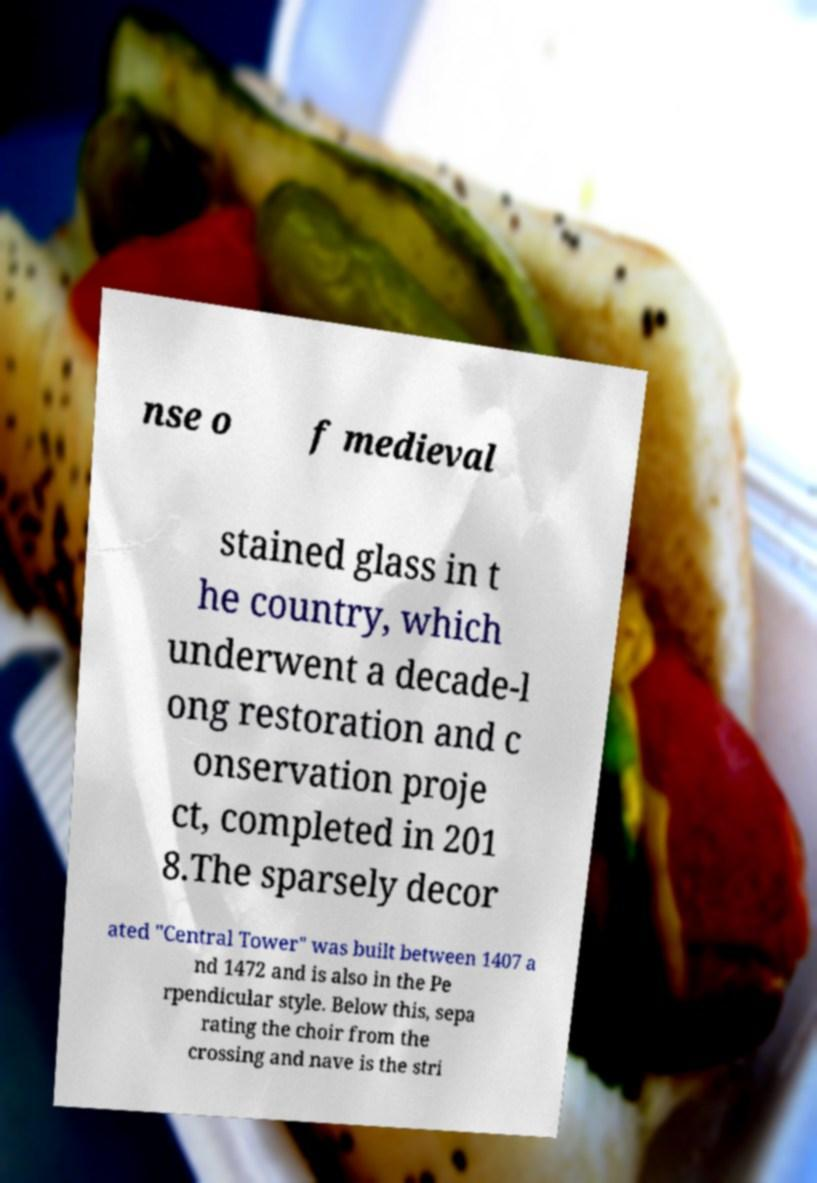I need the written content from this picture converted into text. Can you do that? nse o f medieval stained glass in t he country, which underwent a decade-l ong restoration and c onservation proje ct, completed in 201 8.The sparsely decor ated "Central Tower" was built between 1407 a nd 1472 and is also in the Pe rpendicular style. Below this, sepa rating the choir from the crossing and nave is the stri 